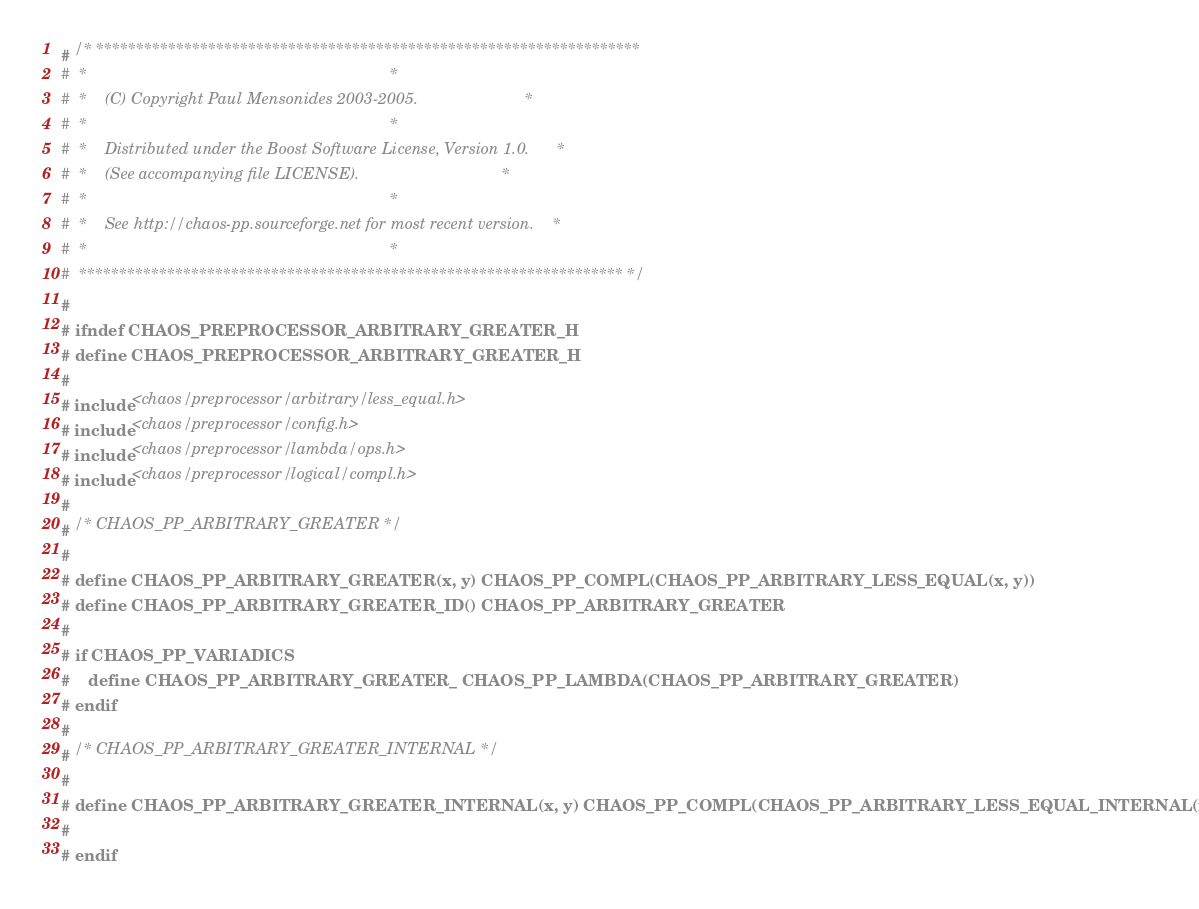<code> <loc_0><loc_0><loc_500><loc_500><_C_># /* ********************************************************************
#  *                                                                    *
#  *    (C) Copyright Paul Mensonides 2003-2005.                        *
#  *                                                                    *
#  *    Distributed under the Boost Software License, Version 1.0.      *
#  *    (See accompanying file LICENSE).                                *
#  *                                                                    *
#  *    See http://chaos-pp.sourceforge.net for most recent version.    *
#  *                                                                    *
#  ******************************************************************** */
#
# ifndef CHAOS_PREPROCESSOR_ARBITRARY_GREATER_H
# define CHAOS_PREPROCESSOR_ARBITRARY_GREATER_H
#
# include <chaos/preprocessor/arbitrary/less_equal.h>
# include <chaos/preprocessor/config.h>
# include <chaos/preprocessor/lambda/ops.h>
# include <chaos/preprocessor/logical/compl.h>
#
# /* CHAOS_PP_ARBITRARY_GREATER */
#
# define CHAOS_PP_ARBITRARY_GREATER(x, y) CHAOS_PP_COMPL(CHAOS_PP_ARBITRARY_LESS_EQUAL(x, y))
# define CHAOS_PP_ARBITRARY_GREATER_ID() CHAOS_PP_ARBITRARY_GREATER
#
# if CHAOS_PP_VARIADICS
#    define CHAOS_PP_ARBITRARY_GREATER_ CHAOS_PP_LAMBDA(CHAOS_PP_ARBITRARY_GREATER)
# endif
#
# /* CHAOS_PP_ARBITRARY_GREATER_INTERNAL */
#
# define CHAOS_PP_ARBITRARY_GREATER_INTERNAL(x, y) CHAOS_PP_COMPL(CHAOS_PP_ARBITRARY_LESS_EQUAL_INTERNAL(x, y))
#
# endif
</code> 